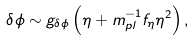Convert formula to latex. <formula><loc_0><loc_0><loc_500><loc_500>\delta \phi \sim g _ { \delta \phi } \left ( \eta + m _ { p l } ^ { - 1 } f _ { \eta } \eta ^ { 2 } \right ) ,</formula> 